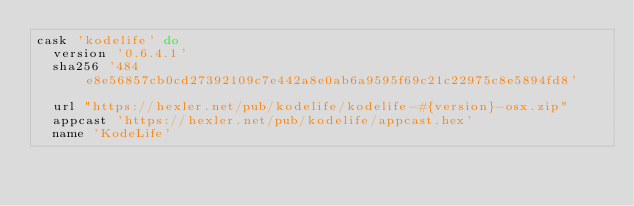<code> <loc_0><loc_0><loc_500><loc_500><_Ruby_>cask 'kodelife' do
  version '0.6.4.1'
  sha256 '484e8e56857cb0cd27392109c7e442a8e0ab6a9595f69c21c22975c8e5894fd8'

  url "https://hexler.net/pub/kodelife/kodelife-#{version}-osx.zip"
  appcast 'https://hexler.net/pub/kodelife/appcast.hex'
  name 'KodeLife'</code> 